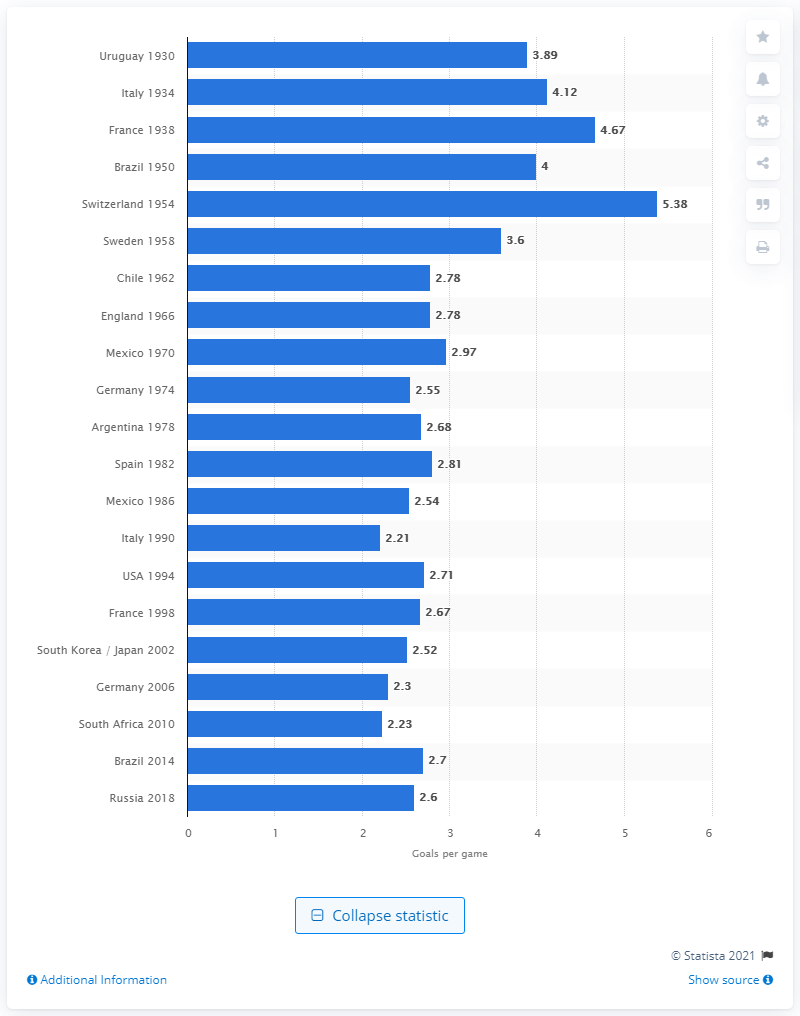Indicate a few pertinent items in this graphic. At the latest World Cup in Russia in 2018, an average of 2.6 goals were scored per game. 